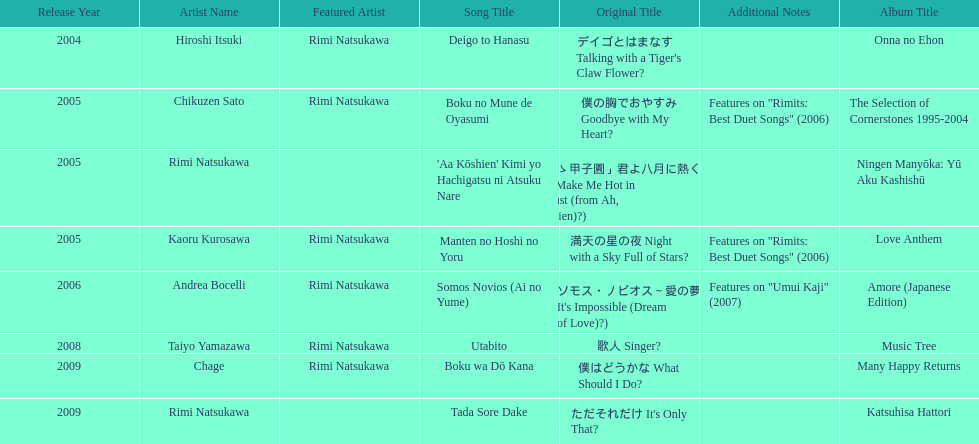What has been the last song this artist has made an other appearance on? Tada Sore Dake. 